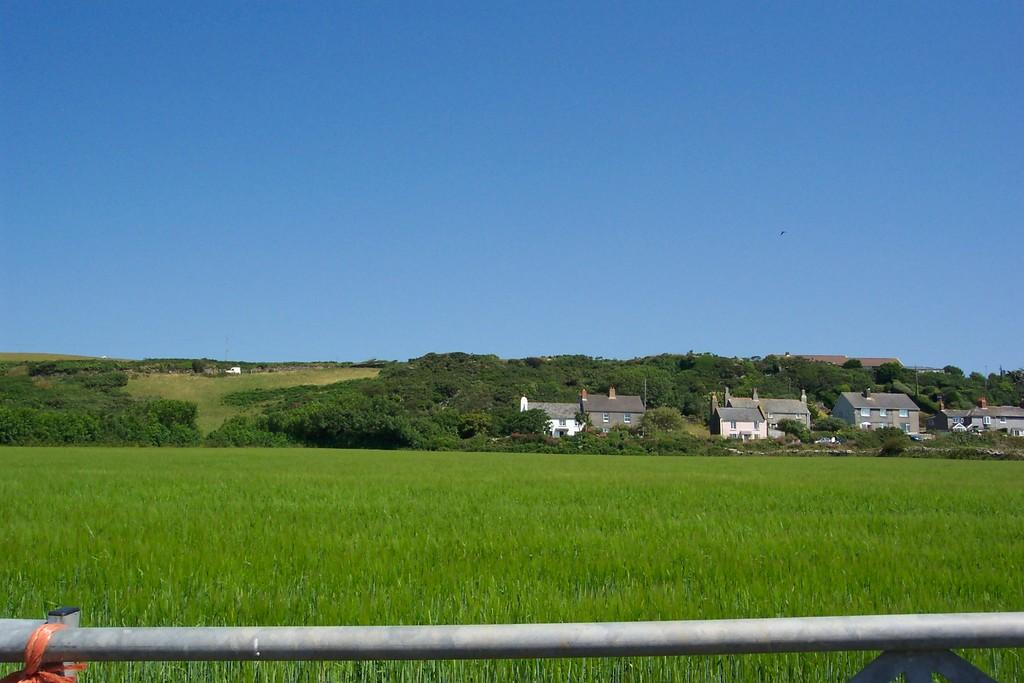What type of natural elements can be seen in the image? There are plants and trees in the image. What type of man-made structures are present in the image? There are buildings in the image. What object can be seen in the image that is not a plant, tree, or building? There is a rod in the image. What can be seen in the background of the image? The sky is visible in the background of the image. What type of home security system is installed in the image? There is no mention of a home security system in the image; it features plants, trees, buildings, a rod, and the sky. 